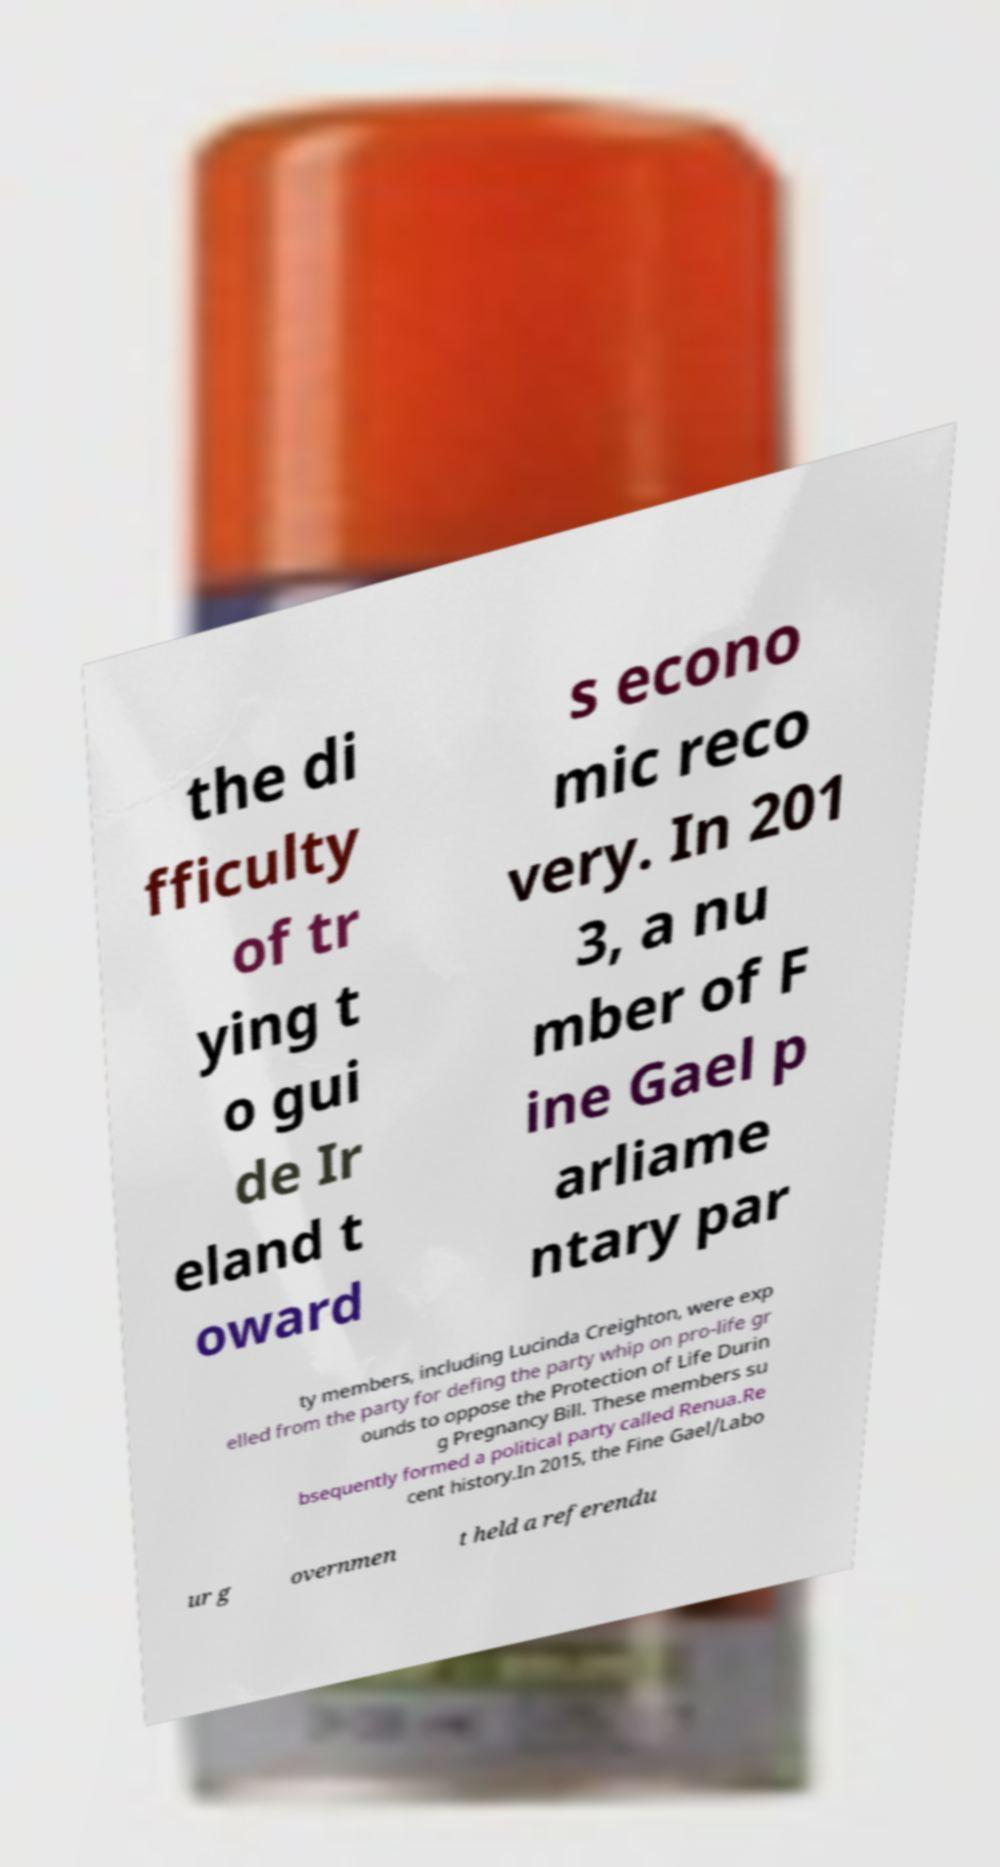Can you read and provide the text displayed in the image?This photo seems to have some interesting text. Can you extract and type it out for me? the di fficulty of tr ying t o gui de Ir eland t oward s econo mic reco very. In 201 3, a nu mber of F ine Gael p arliame ntary par ty members, including Lucinda Creighton, were exp elled from the party for defing the party whip on pro-life gr ounds to oppose the Protection of Life Durin g Pregnancy Bill. These members su bsequently formed a political party called Renua.Re cent history.In 2015, the Fine Gael/Labo ur g overnmen t held a referendu 